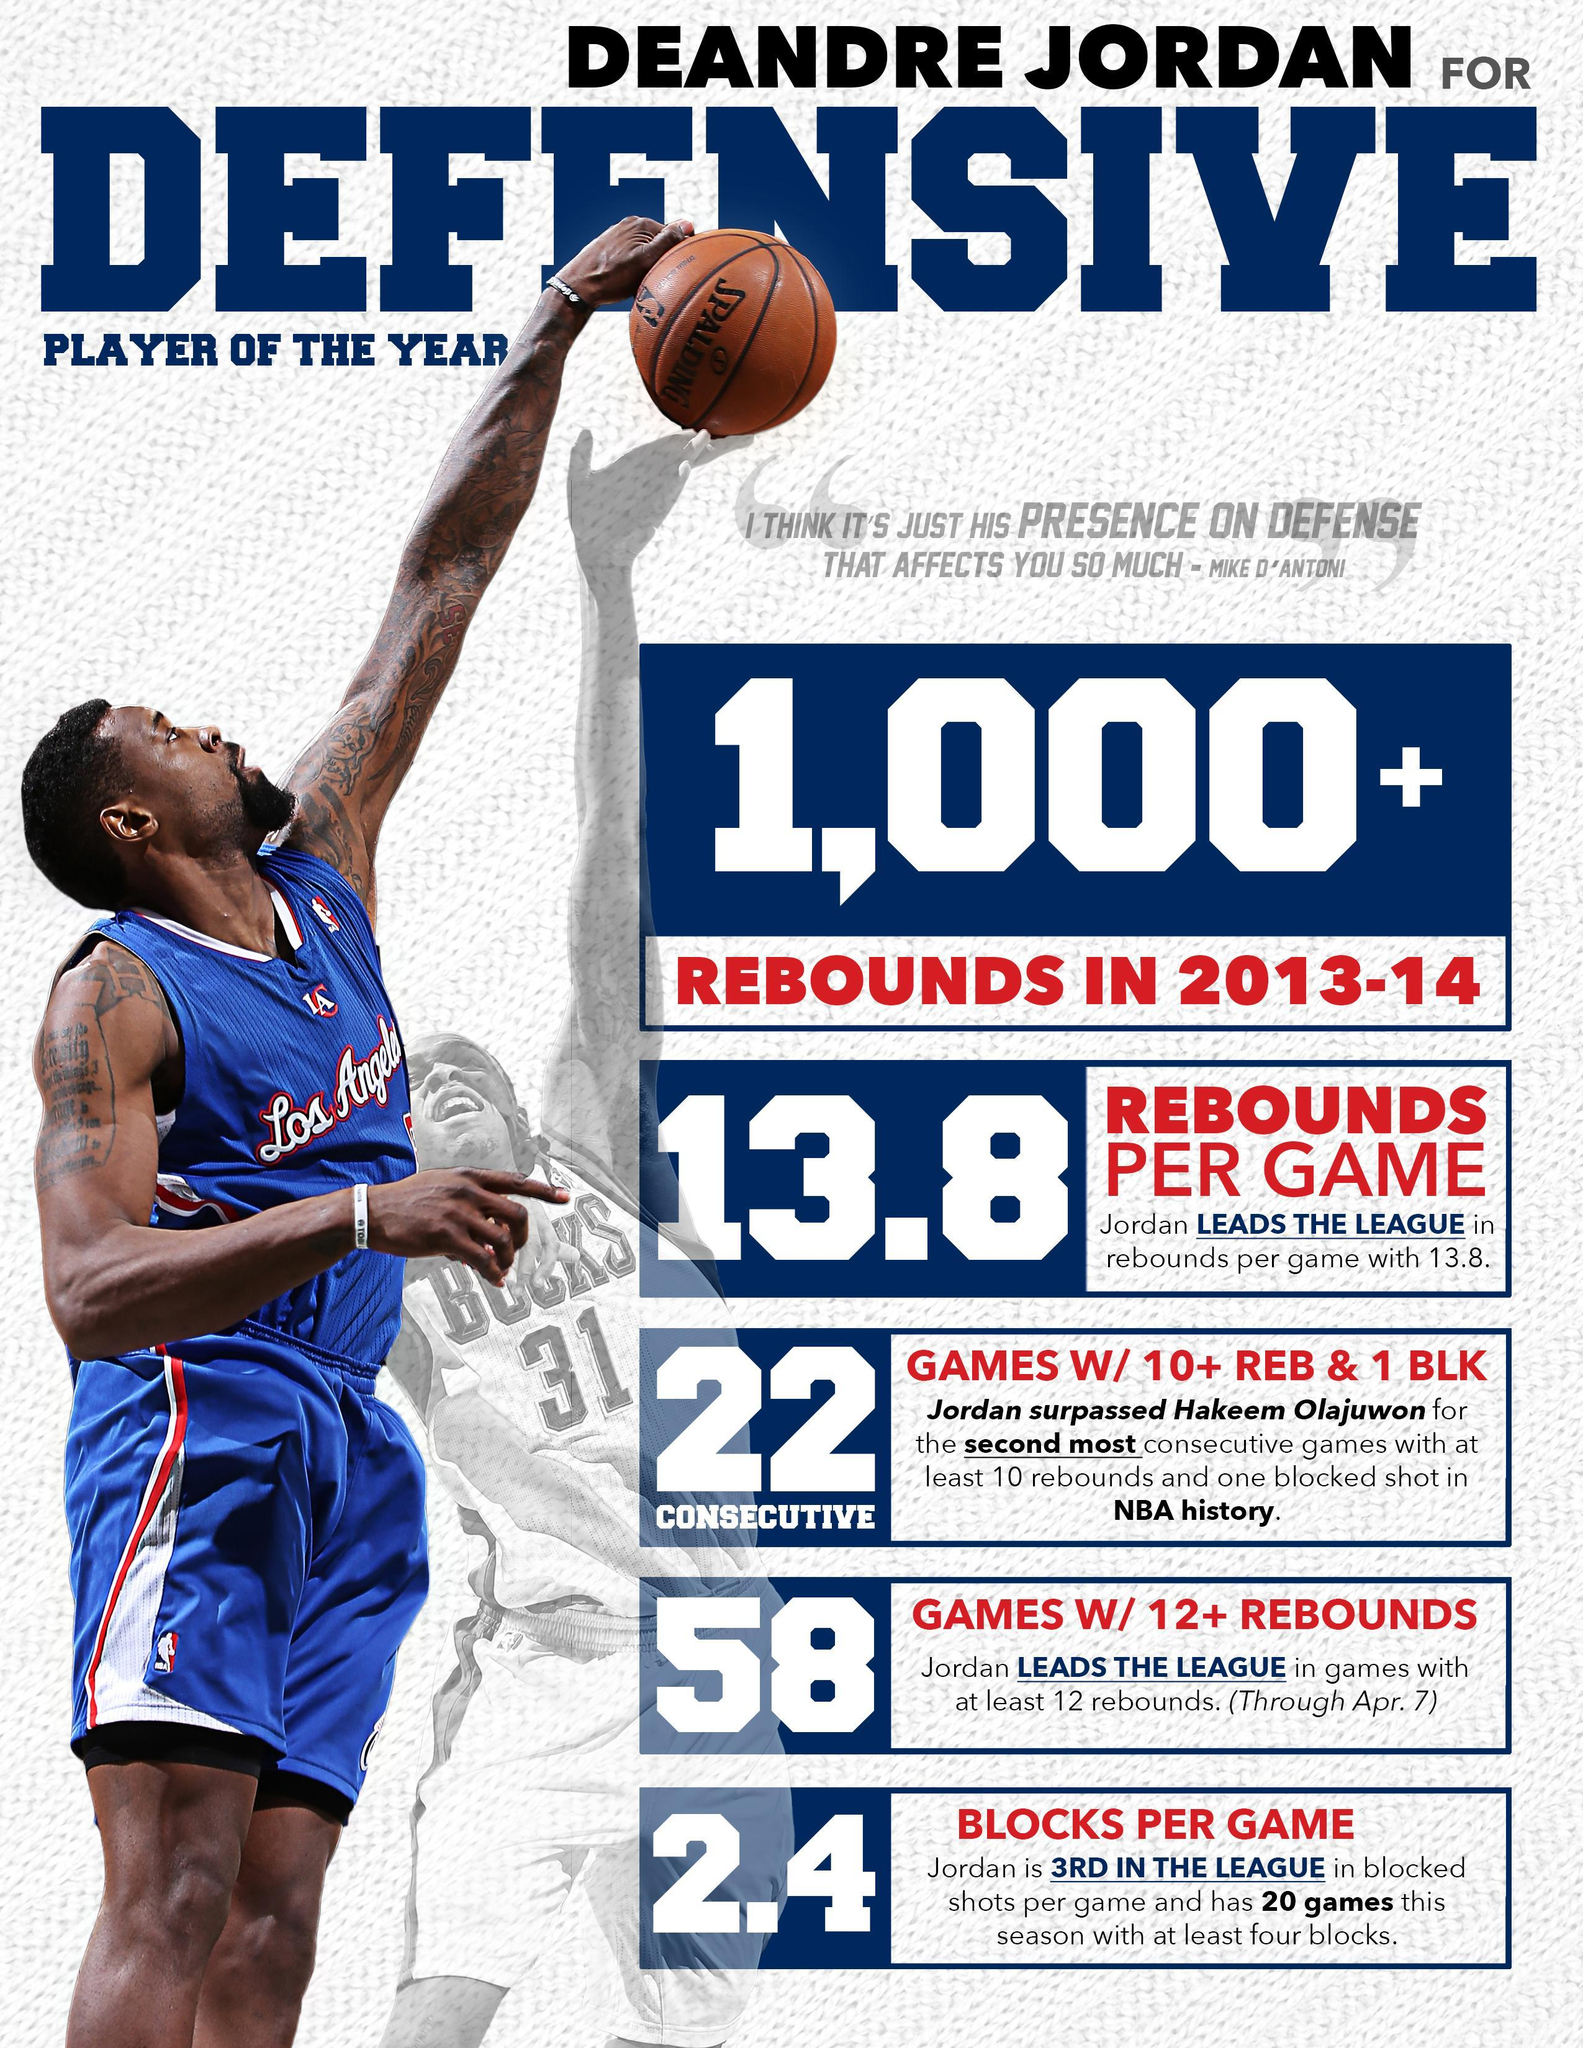What is the color of the T-shirt of Deandre Jordan in this infographic-red, blue, yellow?
Answer the question with a short phrase. blue 